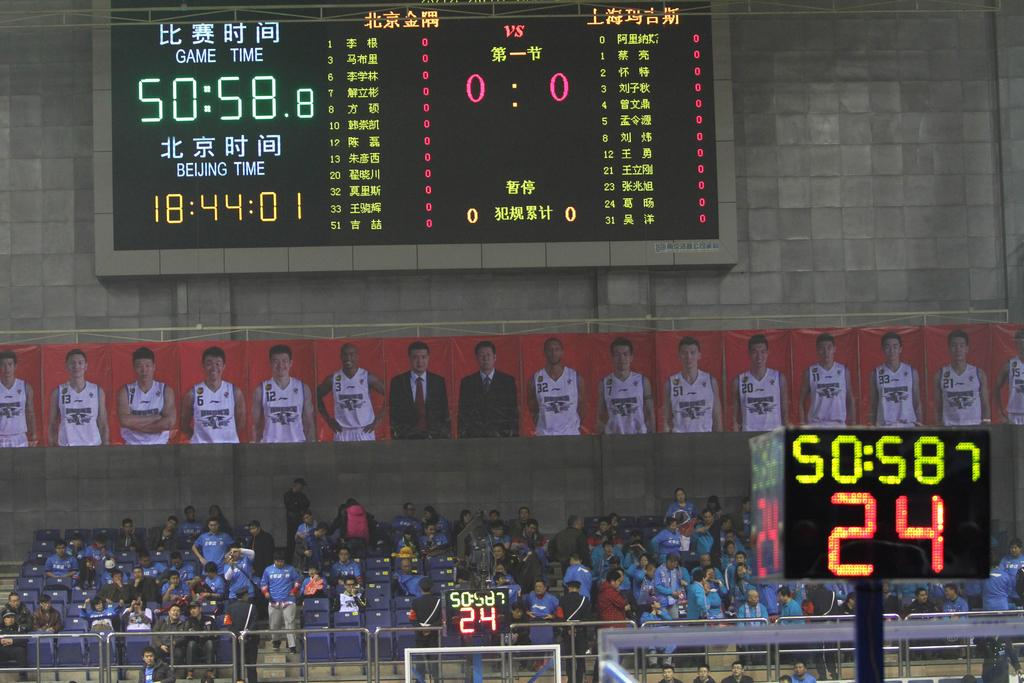<image>
Write a terse but informative summary of the picture. a game that has 24 seconds on the shot clock 